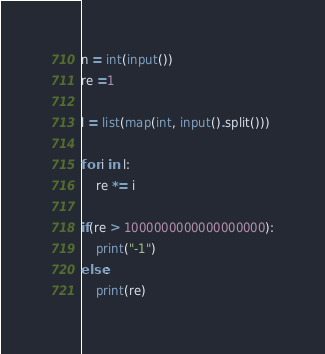Convert code to text. <code><loc_0><loc_0><loc_500><loc_500><_Python_>n = int(input())
re =1

l = list(map(int, input().split()))

for i in l:
    re *= i
    
if(re > 1000000000000000000):
    print("-1")
else:
    print(re)</code> 